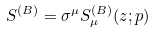Convert formula to latex. <formula><loc_0><loc_0><loc_500><loc_500>S ^ { ( B ) } = \sigma ^ { \mu } S ^ { ( B ) } _ { \mu } ( z ; p )</formula> 